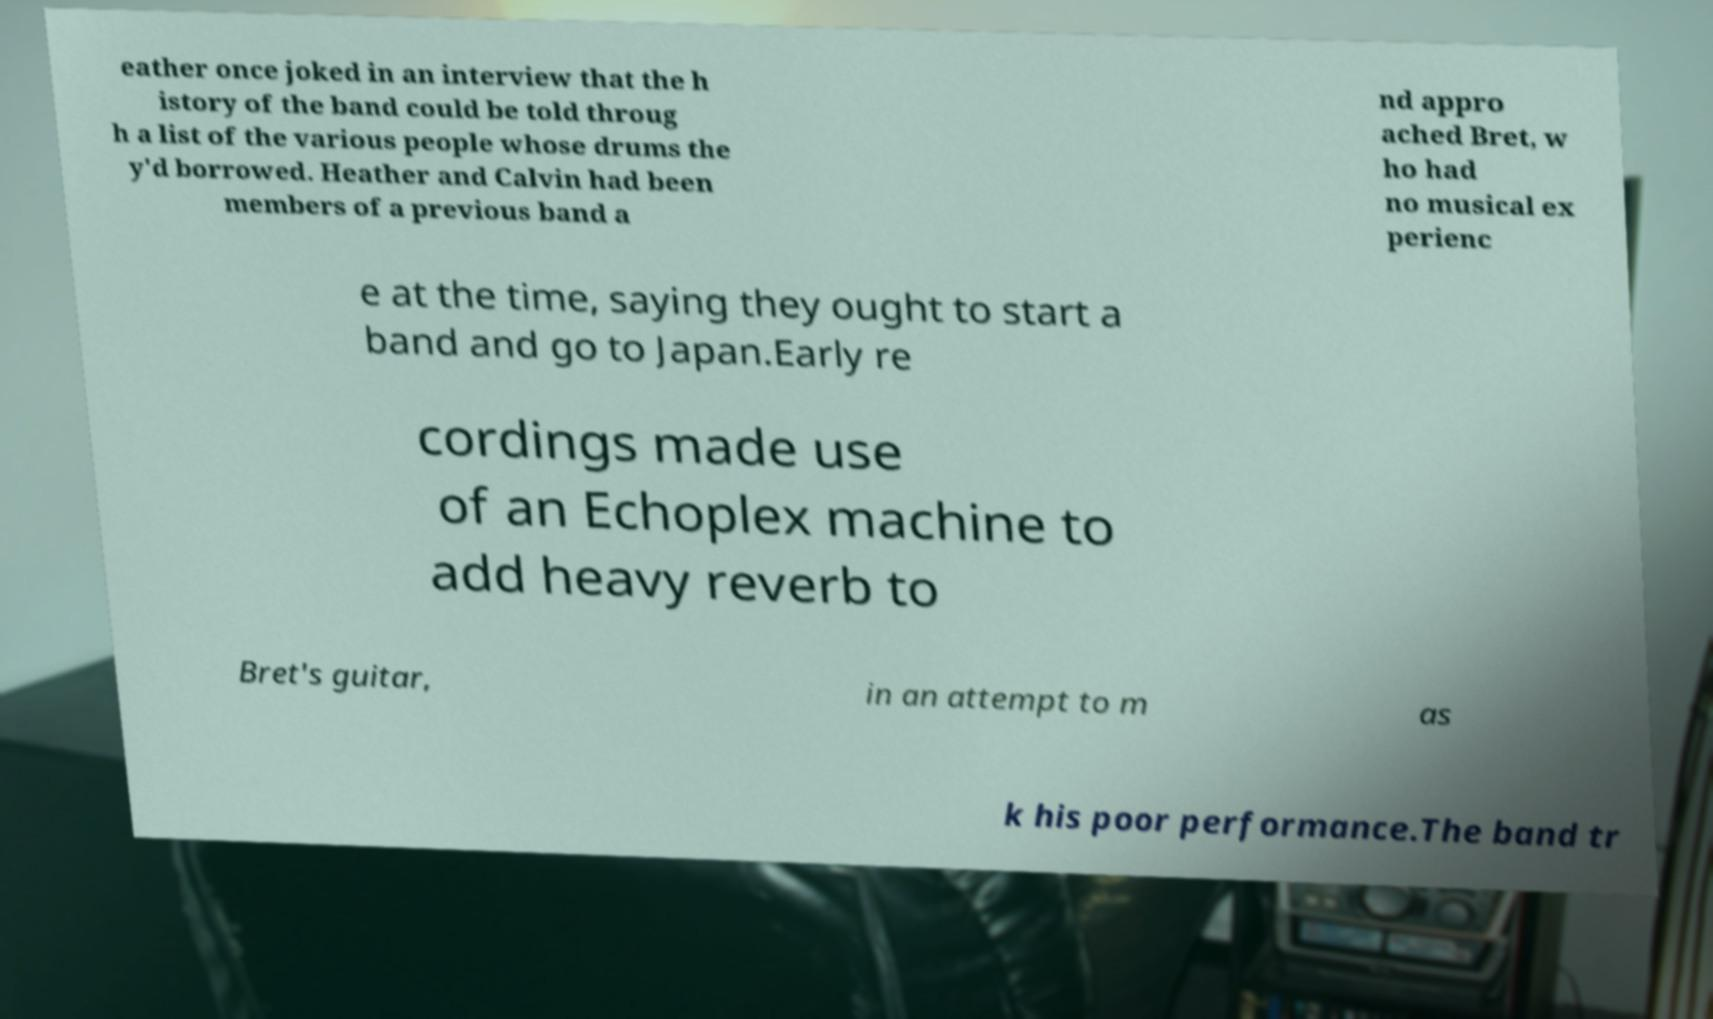What messages or text are displayed in this image? I need them in a readable, typed format. eather once joked in an interview that the h istory of the band could be told throug h a list of the various people whose drums the y'd borrowed. Heather and Calvin had been members of a previous band a nd appro ached Bret, w ho had no musical ex perienc e at the time, saying they ought to start a band and go to Japan.Early re cordings made use of an Echoplex machine to add heavy reverb to Bret's guitar, in an attempt to m as k his poor performance.The band tr 